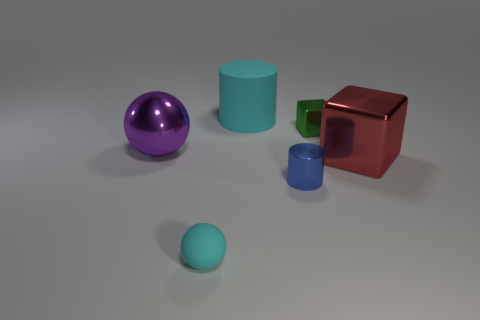There is a matte object behind the small cyan ball; is it the same color as the sphere that is in front of the purple metallic sphere?
Offer a terse response. Yes. What is the material of the purple ball that is the same size as the red metal block?
Give a very brief answer. Metal. There is a green thing that is the same shape as the red thing; what is its material?
Keep it short and to the point. Metal. Are there more matte balls that are behind the small green metal cube than big brown metallic cylinders?
Ensure brevity in your answer.  No. There is a cyan matte object in front of the blue metallic thing; is it the same size as the large cyan object?
Give a very brief answer. No. There is a object that is both in front of the big block and left of the blue cylinder; what color is it?
Ensure brevity in your answer.  Cyan. What is the shape of the red object that is the same size as the metal ball?
Give a very brief answer. Cube. Are there any other rubber things that have the same color as the big matte thing?
Give a very brief answer. Yes. Is the number of small green metallic things left of the green thing the same as the number of metallic balls?
Give a very brief answer. No. Do the shiny cylinder and the large metal block have the same color?
Offer a very short reply. No. 